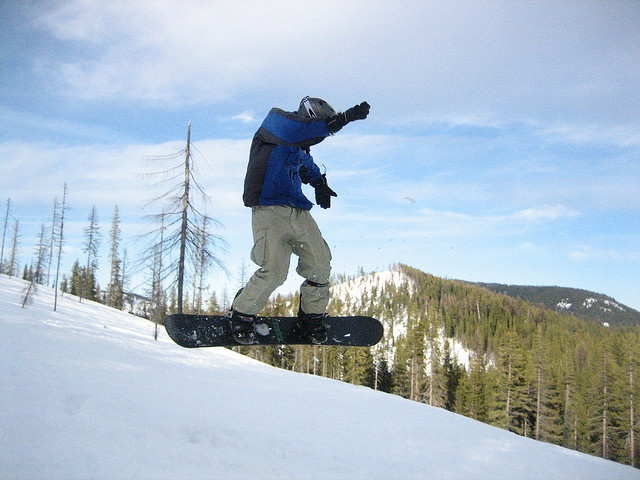Describe the objects in this image and their specific colors. I can see people in gray, black, and navy tones and snowboard in gray, black, and white tones in this image. 